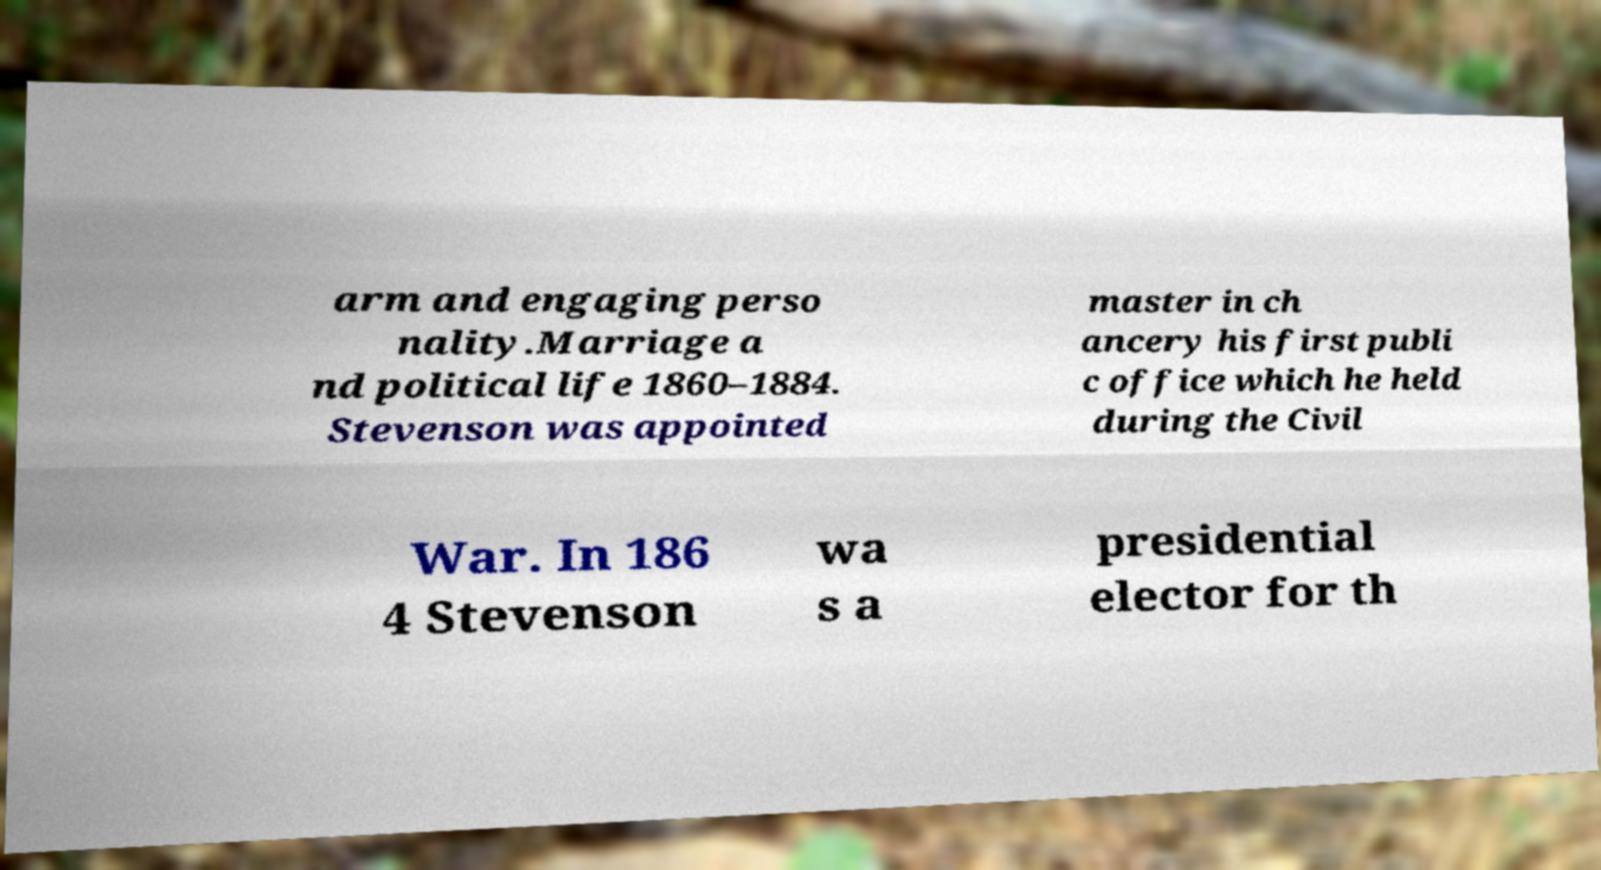Please identify and transcribe the text found in this image. arm and engaging perso nality.Marriage a nd political life 1860–1884. Stevenson was appointed master in ch ancery his first publi c office which he held during the Civil War. In 186 4 Stevenson wa s a presidential elector for th 